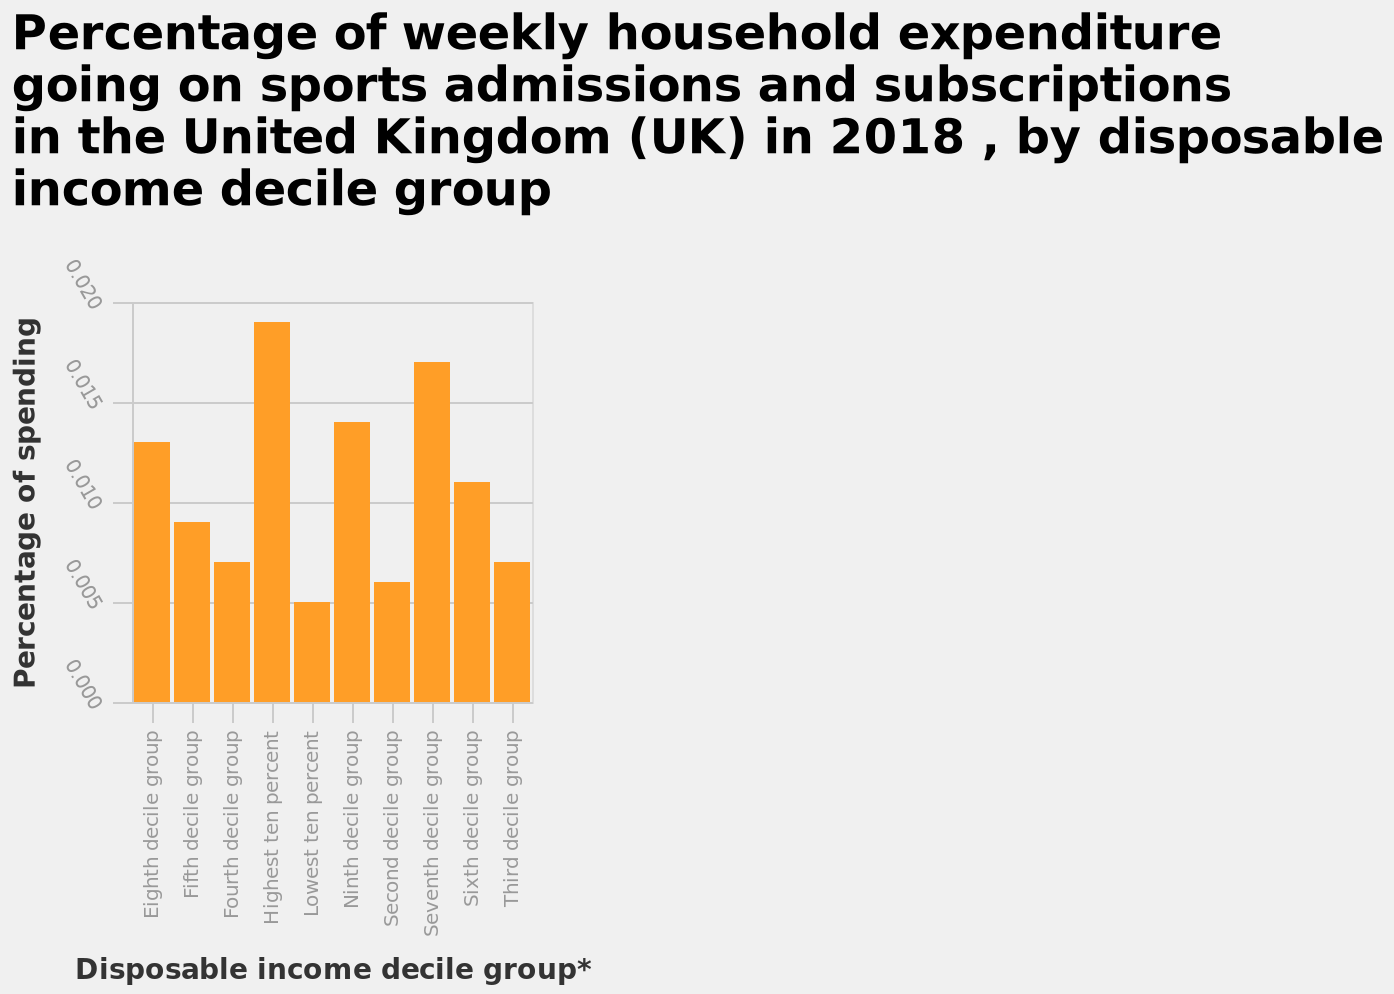<image>
What is the highest decile group labeled on the x-axis? The highest decile group labeled on the x-axis is the Third decile group. Is there a general trend in expenditure based on the percentage decile group? Yes, there is a general increase in expenditure with the higher percentage decile group. What is the title of the bar graph?  The title of the bar graph is "Percentage of weekly household expenditure going on sports admissions and subscriptions in the United Kingdom (UK) in 2018, by disposable income decile group." Which decile group is labeled at the start of the x-axis?  The Eighth decile group is labeled at the start of the x-axis. 